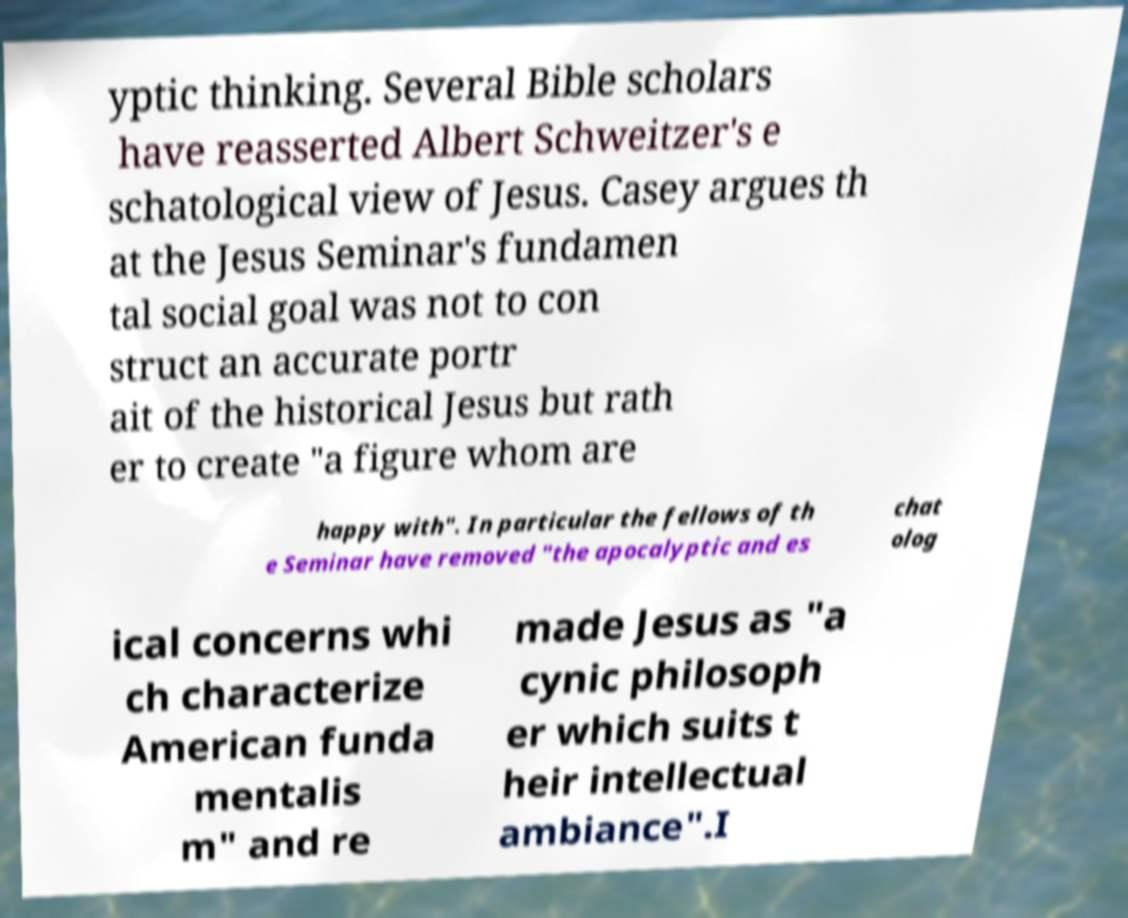Please read and relay the text visible in this image. What does it say? yptic thinking. Several Bible scholars have reasserted Albert Schweitzer's e schatological view of Jesus. Casey argues th at the Jesus Seminar's fundamen tal social goal was not to con struct an accurate portr ait of the historical Jesus but rath er to create "a figure whom are happy with". In particular the fellows of th e Seminar have removed "the apocalyptic and es chat olog ical concerns whi ch characterize American funda mentalis m" and re made Jesus as "a cynic philosoph er which suits t heir intellectual ambiance".I 